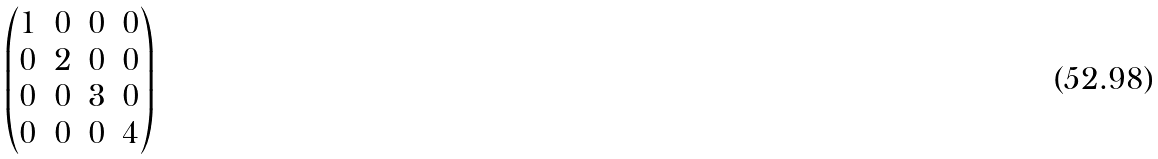<formula> <loc_0><loc_0><loc_500><loc_500>\begin{pmatrix} 1 & 0 & 0 & 0 \\ 0 & 2 & 0 & 0 \\ 0 & 0 & 3 & 0 \\ 0 & 0 & 0 & 4 \end{pmatrix}</formula> 